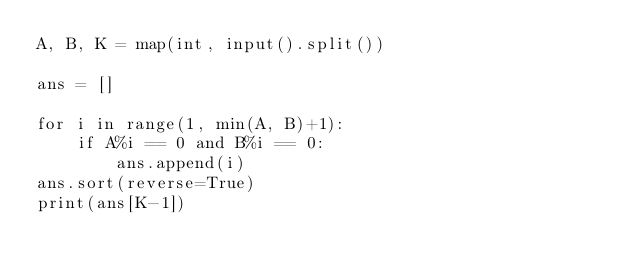Convert code to text. <code><loc_0><loc_0><loc_500><loc_500><_Python_>A, B, K = map(int, input().split())

ans = []

for i in range(1, min(A, B)+1):
    if A%i == 0 and B%i == 0:
        ans.append(i)
ans.sort(reverse=True)
print(ans[K-1])</code> 